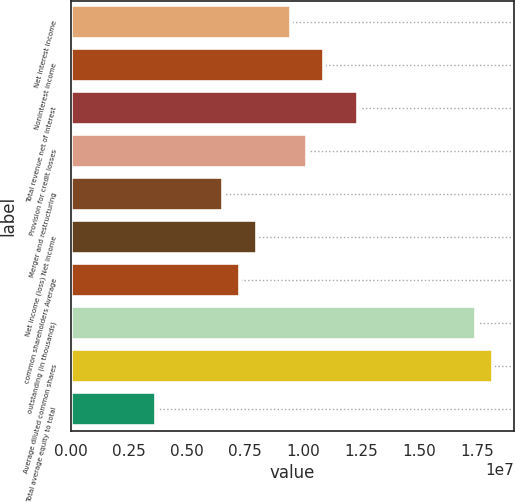Convert chart. <chart><loc_0><loc_0><loc_500><loc_500><bar_chart><fcel>Net interest income<fcel>Noninterest income<fcel>Total revenue net of interest<fcel>Provision for credit losses<fcel>Merger and restructuring<fcel>Net income (loss) Net income<fcel>common shareholders Average<fcel>outstanding (in thousands)<fcel>Average diluted common shares<fcel>Total average equity to total<nl><fcel>9.45037e+06<fcel>1.09043e+07<fcel>1.23582e+07<fcel>1.01773e+07<fcel>6.54257e+06<fcel>7.99647e+06<fcel>7.26952e+06<fcel>1.74468e+07<fcel>1.81738e+07<fcel>3.63476e+06<nl></chart> 